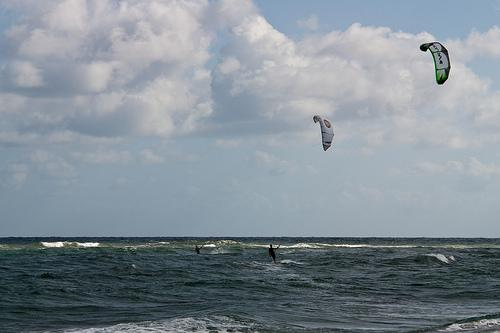Question: how many animals are seen?
Choices:
A. Zero.
B. One.
C. Two.
D. Three.
Answer with the letter. Answer: A Question: why is the picture clear?
Choices:
A. The light is on.
B. It's not raining.
C. The sunlight.
D. The lens is clear.
Answer with the letter. Answer: C Question: where is this scene?
Choices:
A. At the park.
B. In an office.
C. At a restaurant.
D. The ocean.
Answer with the letter. Answer: D 